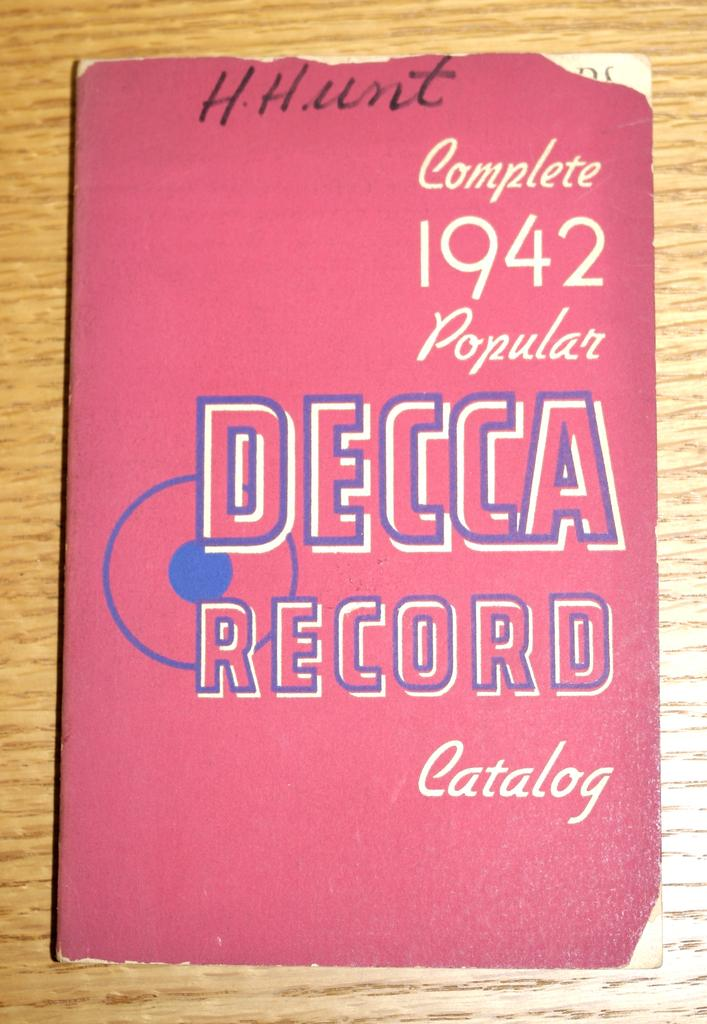<image>
Summarize the visual content of the image. The cover of the Complete 1942 Popular Decca Record Catalog is shown. 